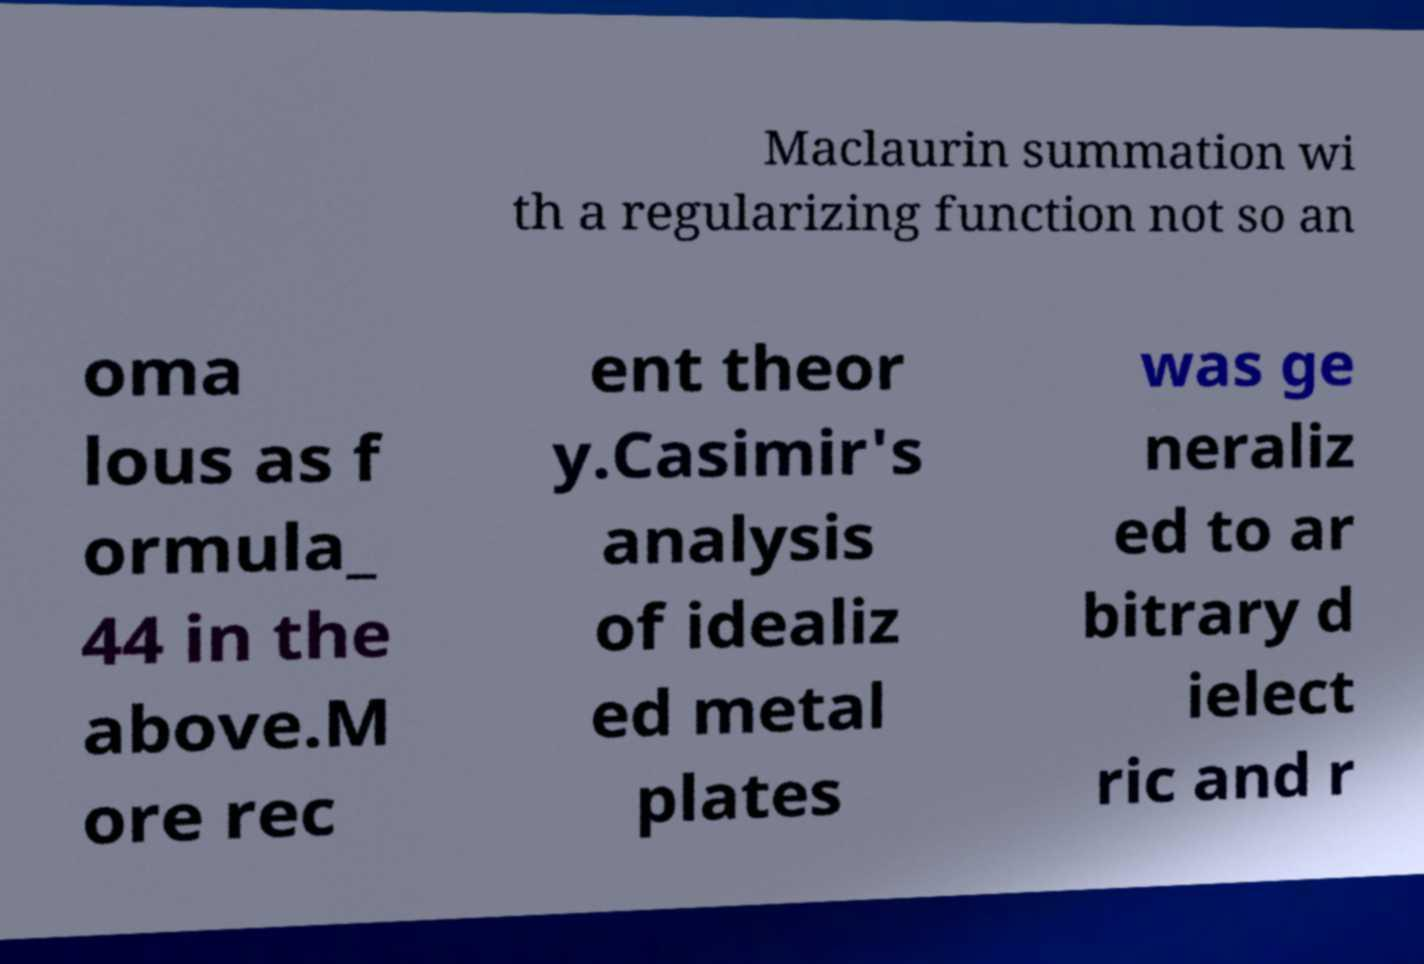Could you assist in decoding the text presented in this image and type it out clearly? Maclaurin summation wi th a regularizing function not so an oma lous as f ormula_ 44 in the above.M ore rec ent theor y.Casimir's analysis of idealiz ed metal plates was ge neraliz ed to ar bitrary d ielect ric and r 